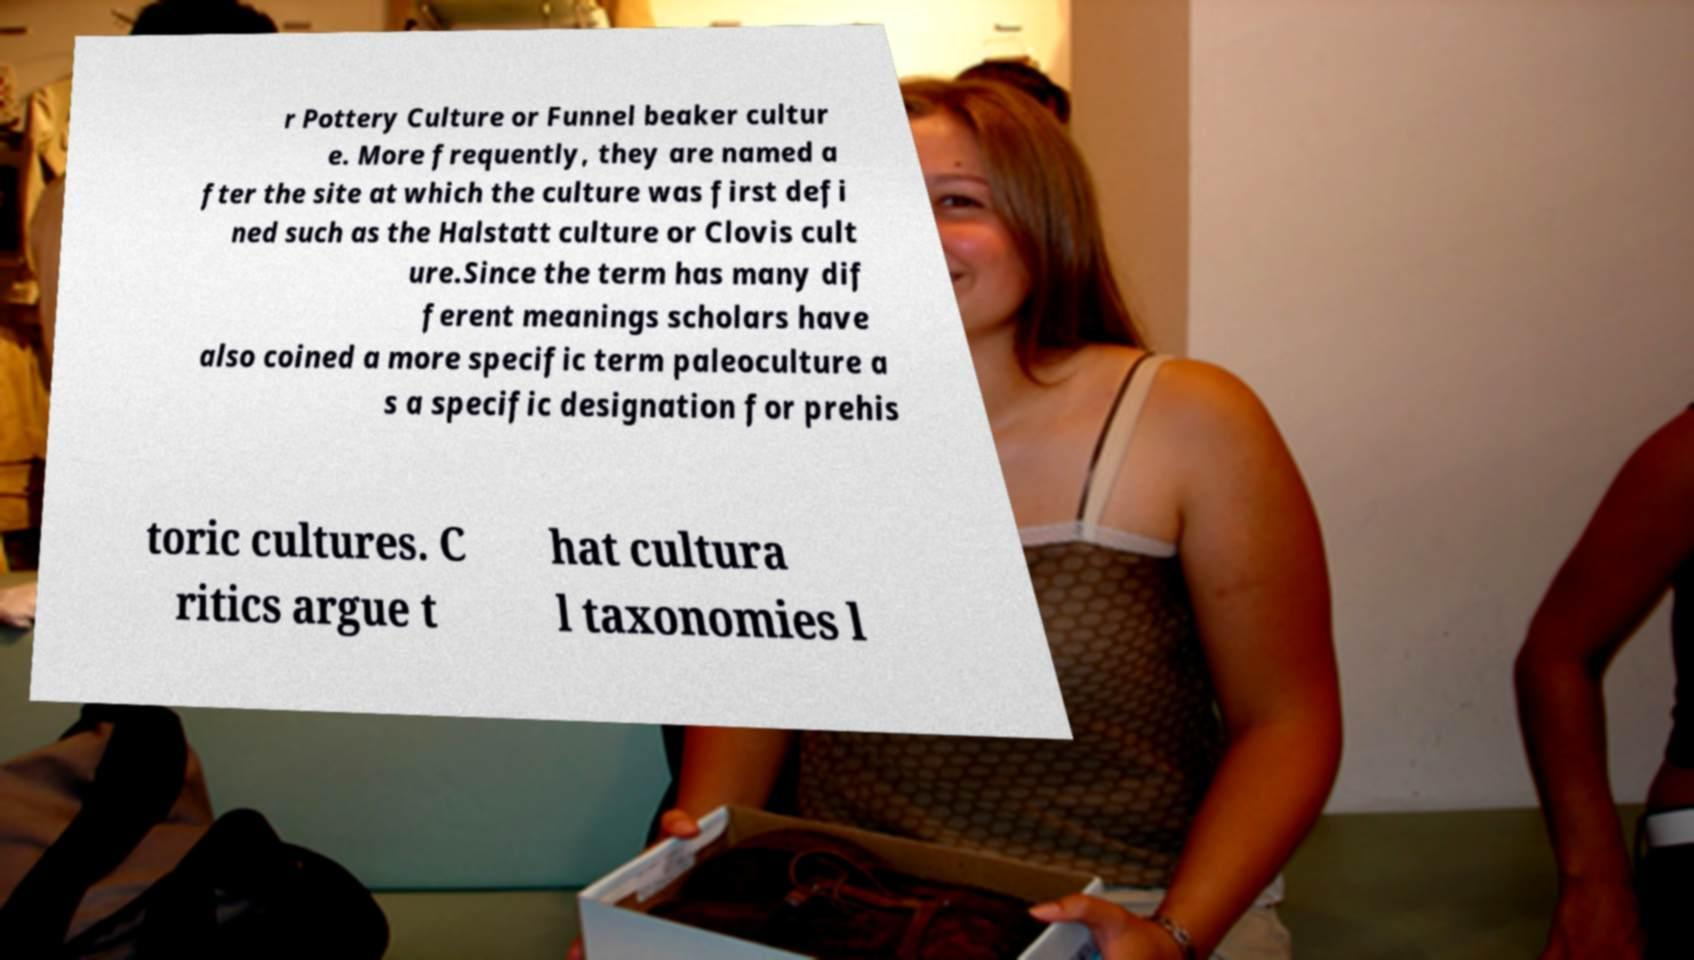Can you accurately transcribe the text from the provided image for me? r Pottery Culture or Funnel beaker cultur e. More frequently, they are named a fter the site at which the culture was first defi ned such as the Halstatt culture or Clovis cult ure.Since the term has many dif ferent meanings scholars have also coined a more specific term paleoculture a s a specific designation for prehis toric cultures. C ritics argue t hat cultura l taxonomies l 